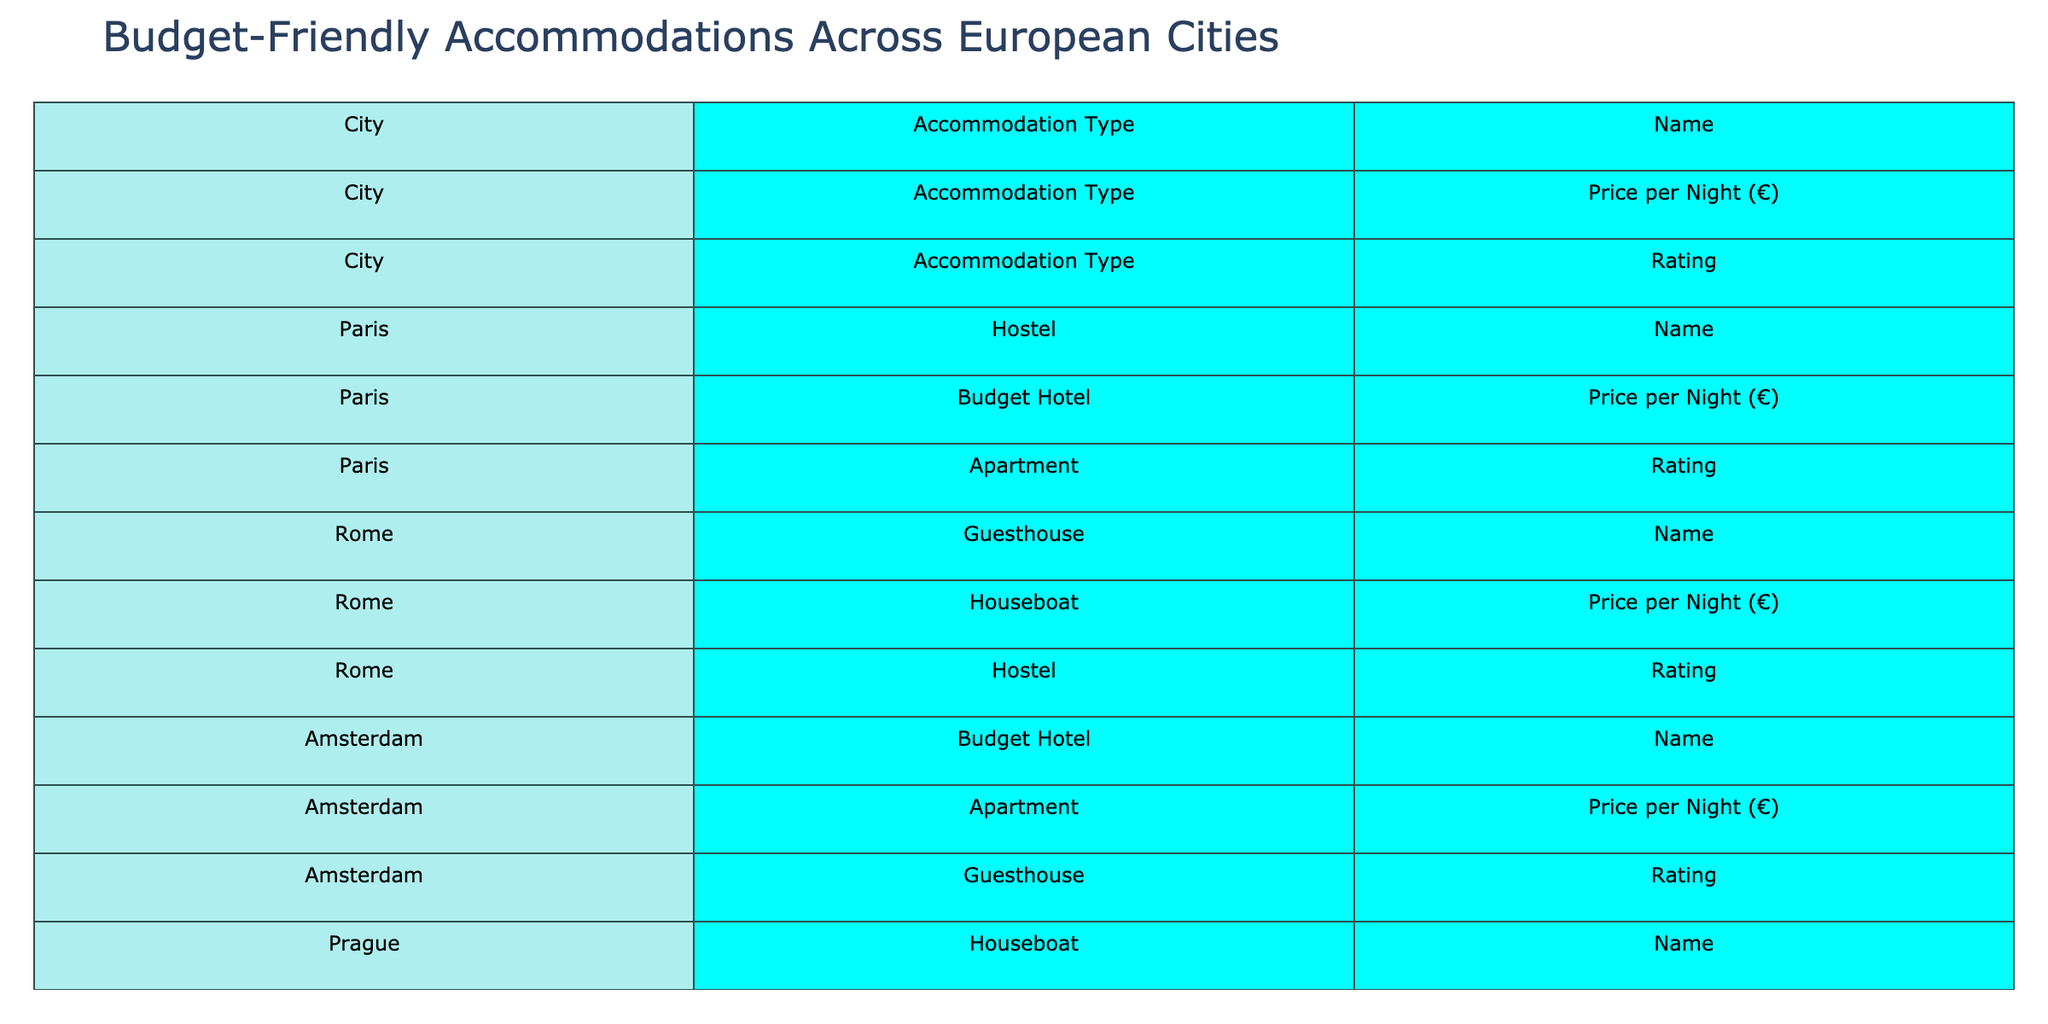What is the price per night for the Le Village Montmartre in Paris? The table shows that the price for Le Village Montmartre is listed under the "Price per Night (€)" column in the row for Paris and Hostel type. The value is 25.
Answer: 25 Which accommodation in Rome has the highest rating? By examining the "Rating" column for all accommodations in Rome, Dreaming Rome is listed as having the highest rating of 4.6.
Answer: Dreaming Rome What is the average price per night for budget hotels listed in the table? The budget hotels and their prices are: Hôtel Tiquetonne (60), Hotel Papa Germano (55), Hotel Alfa Plantage (70), Residence BENE (50), Huttenpalast (65), Chic & Basic Born (75), Pensão Londres (55), Bohem Art Hotel (65), Boutique Hotel Donauwalzer (70). The average is (60 + 55 + 70 + 50 + 65 + 75 + 55 + 65 + 70)/9 = 62.22.
Answer: 62.22 Which city has the most accommodations listed in the table? By counting the number of entries for each city, I find that Paris has 3, Rome has 3, Amsterdam has 3, Prague has 3, Berlin has 3, Barcelona has 3, Lisbon has 3, Budapest has 3, and Vienna has 3, making all cities equal.
Answer: All cities have the same number of accommodations Is there a hostel in Budapest with a rating above 4.5? Referring to the Budapest hostel entries, Carpe Noctem Original has a rating of 4.6, which is indeed above 4.5.
Answer: Yes What notable feature does the Old Town Square Studios in Prague have? Looking at the notable feature column for Old Town Square Studios, it states that it is located in a historic building with city views.
Answer: Historic building with city views How does the price of the Gothic Quarter Loft compare to the price of the Marais Studio in Paris? The price for Gothic Quarter Loft is 95 and for Marais Studio is 75. The difference is 95 - 75 = 20, making the Gothic Quarter Loft more expensive by 20.
Answer: Gothic Quarter Loft is 20 more expensive What city features budget hotels with traditional charm? By examining the notable features, the budget hotels in Vienna, specifically Boutique Hotel Donauwalzer, are described as having traditional Viennese charm.
Answer: Vienna Which apartment in Amsterdam has the highest rating? In the Amsterdam section, the Canal View Houseboat is listed with a rating of 4.4 while the Marais Studio in Paris rates 4.5, indicating that Canal View Houseboat has a lower score. Therefore, the best-rated apartment in Amsterdam is Canal View Houseboat at 4.4.
Answer: Canal View Houseboat What is the notable feature of Home Lisbon Hostel? The notable feature for Home Lisbon Hostel highlights famous family-style dinners.
Answer: Famous family-style dinners 